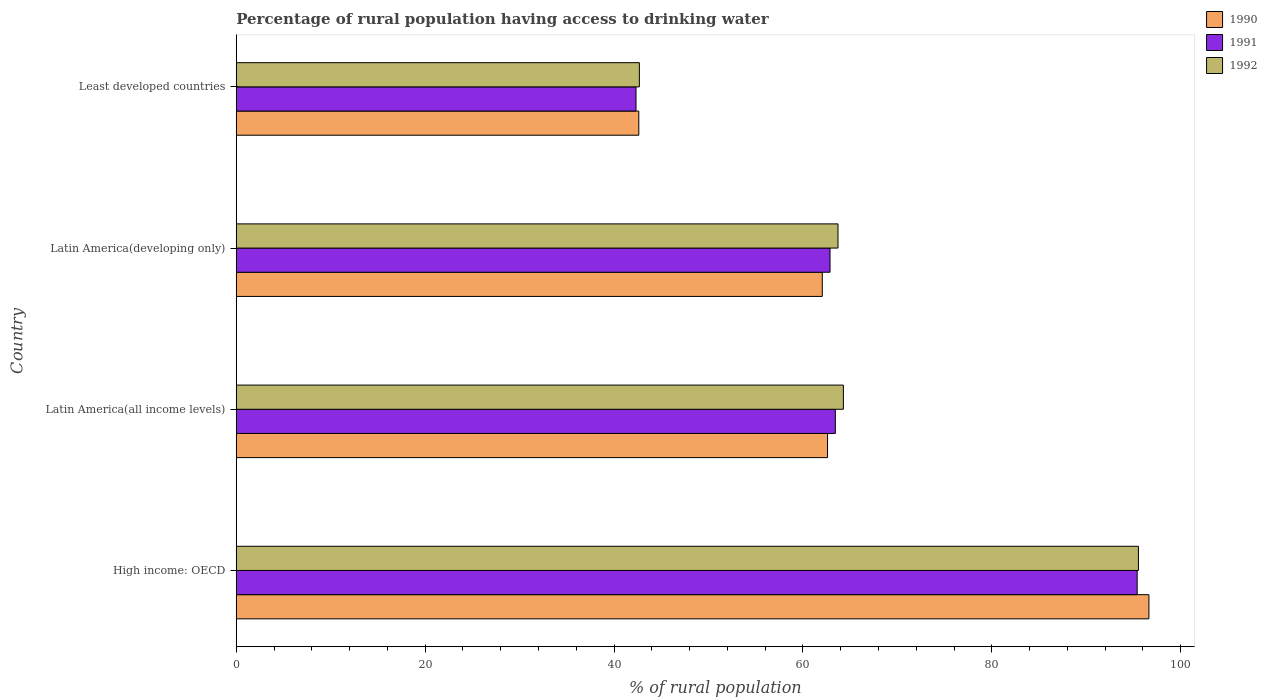How many bars are there on the 2nd tick from the top?
Give a very brief answer. 3. What is the label of the 2nd group of bars from the top?
Your answer should be compact. Latin America(developing only). What is the percentage of rural population having access to drinking water in 1992 in High income: OECD?
Give a very brief answer. 95.52. Across all countries, what is the maximum percentage of rural population having access to drinking water in 1990?
Provide a succinct answer. 96.63. Across all countries, what is the minimum percentage of rural population having access to drinking water in 1992?
Provide a succinct answer. 42.68. In which country was the percentage of rural population having access to drinking water in 1991 maximum?
Give a very brief answer. High income: OECD. In which country was the percentage of rural population having access to drinking water in 1992 minimum?
Ensure brevity in your answer.  Least developed countries. What is the total percentage of rural population having access to drinking water in 1991 in the graph?
Offer a very short reply. 264.02. What is the difference between the percentage of rural population having access to drinking water in 1991 in Latin America(developing only) and that in Least developed countries?
Offer a terse response. 20.54. What is the difference between the percentage of rural population having access to drinking water in 1990 in Latin America(all income levels) and the percentage of rural population having access to drinking water in 1992 in Latin America(developing only)?
Provide a succinct answer. -1.11. What is the average percentage of rural population having access to drinking water in 1992 per country?
Offer a very short reply. 66.55. What is the difference between the percentage of rural population having access to drinking water in 1991 and percentage of rural population having access to drinking water in 1992 in High income: OECD?
Your answer should be very brief. -0.14. In how many countries, is the percentage of rural population having access to drinking water in 1991 greater than 80 %?
Ensure brevity in your answer.  1. What is the ratio of the percentage of rural population having access to drinking water in 1990 in Latin America(all income levels) to that in Least developed countries?
Offer a terse response. 1.47. Is the percentage of rural population having access to drinking water in 1991 in High income: OECD less than that in Latin America(all income levels)?
Your answer should be very brief. No. What is the difference between the highest and the second highest percentage of rural population having access to drinking water in 1991?
Your response must be concise. 31.96. What is the difference between the highest and the lowest percentage of rural population having access to drinking water in 1992?
Keep it short and to the point. 52.84. In how many countries, is the percentage of rural population having access to drinking water in 1990 greater than the average percentage of rural population having access to drinking water in 1990 taken over all countries?
Provide a short and direct response. 1. Is the sum of the percentage of rural population having access to drinking water in 1990 in High income: OECD and Latin America(developing only) greater than the maximum percentage of rural population having access to drinking water in 1991 across all countries?
Give a very brief answer. Yes. What does the 2nd bar from the top in Latin America(developing only) represents?
Keep it short and to the point. 1991. What does the 3rd bar from the bottom in Latin America(developing only) represents?
Provide a succinct answer. 1992. Is it the case that in every country, the sum of the percentage of rural population having access to drinking water in 1990 and percentage of rural population having access to drinking water in 1992 is greater than the percentage of rural population having access to drinking water in 1991?
Provide a succinct answer. Yes. How many countries are there in the graph?
Provide a succinct answer. 4. Are the values on the major ticks of X-axis written in scientific E-notation?
Give a very brief answer. No. Does the graph contain grids?
Give a very brief answer. No. How many legend labels are there?
Give a very brief answer. 3. What is the title of the graph?
Offer a very short reply. Percentage of rural population having access to drinking water. Does "1991" appear as one of the legend labels in the graph?
Your answer should be compact. Yes. What is the label or title of the X-axis?
Provide a short and direct response. % of rural population. What is the label or title of the Y-axis?
Make the answer very short. Country. What is the % of rural population in 1990 in High income: OECD?
Make the answer very short. 96.63. What is the % of rural population in 1991 in High income: OECD?
Provide a short and direct response. 95.39. What is the % of rural population in 1992 in High income: OECD?
Offer a terse response. 95.52. What is the % of rural population in 1990 in Latin America(all income levels)?
Ensure brevity in your answer.  62.61. What is the % of rural population in 1991 in Latin America(all income levels)?
Your answer should be compact. 63.43. What is the % of rural population in 1992 in Latin America(all income levels)?
Ensure brevity in your answer.  64.28. What is the % of rural population in 1990 in Latin America(developing only)?
Provide a short and direct response. 62.05. What is the % of rural population of 1991 in Latin America(developing only)?
Offer a very short reply. 62.87. What is the % of rural population of 1992 in Latin America(developing only)?
Make the answer very short. 63.71. What is the % of rural population in 1990 in Least developed countries?
Provide a short and direct response. 42.62. What is the % of rural population of 1991 in Least developed countries?
Your response must be concise. 42.33. What is the % of rural population in 1992 in Least developed countries?
Your answer should be compact. 42.68. Across all countries, what is the maximum % of rural population of 1990?
Keep it short and to the point. 96.63. Across all countries, what is the maximum % of rural population in 1991?
Your answer should be very brief. 95.39. Across all countries, what is the maximum % of rural population in 1992?
Ensure brevity in your answer.  95.52. Across all countries, what is the minimum % of rural population in 1990?
Your answer should be very brief. 42.62. Across all countries, what is the minimum % of rural population in 1991?
Give a very brief answer. 42.33. Across all countries, what is the minimum % of rural population in 1992?
Offer a very short reply. 42.68. What is the total % of rural population of 1990 in the graph?
Your answer should be compact. 263.91. What is the total % of rural population in 1991 in the graph?
Make the answer very short. 264.01. What is the total % of rural population of 1992 in the graph?
Offer a very short reply. 266.2. What is the difference between the % of rural population of 1990 in High income: OECD and that in Latin America(all income levels)?
Provide a short and direct response. 34.03. What is the difference between the % of rural population in 1991 in High income: OECD and that in Latin America(all income levels)?
Keep it short and to the point. 31.96. What is the difference between the % of rural population of 1992 in High income: OECD and that in Latin America(all income levels)?
Ensure brevity in your answer.  31.24. What is the difference between the % of rural population of 1990 in High income: OECD and that in Latin America(developing only)?
Your answer should be very brief. 34.58. What is the difference between the % of rural population of 1991 in High income: OECD and that in Latin America(developing only)?
Your answer should be compact. 32.52. What is the difference between the % of rural population of 1992 in High income: OECD and that in Latin America(developing only)?
Ensure brevity in your answer.  31.81. What is the difference between the % of rural population of 1990 in High income: OECD and that in Least developed countries?
Your response must be concise. 54.01. What is the difference between the % of rural population of 1991 in High income: OECD and that in Least developed countries?
Ensure brevity in your answer.  53.06. What is the difference between the % of rural population in 1992 in High income: OECD and that in Least developed countries?
Your response must be concise. 52.84. What is the difference between the % of rural population of 1990 in Latin America(all income levels) and that in Latin America(developing only)?
Keep it short and to the point. 0.56. What is the difference between the % of rural population in 1991 in Latin America(all income levels) and that in Latin America(developing only)?
Ensure brevity in your answer.  0.56. What is the difference between the % of rural population of 1990 in Latin America(all income levels) and that in Least developed countries?
Provide a succinct answer. 19.99. What is the difference between the % of rural population in 1991 in Latin America(all income levels) and that in Least developed countries?
Ensure brevity in your answer.  21.11. What is the difference between the % of rural population of 1992 in Latin America(all income levels) and that in Least developed countries?
Provide a succinct answer. 21.6. What is the difference between the % of rural population in 1990 in Latin America(developing only) and that in Least developed countries?
Your answer should be very brief. 19.43. What is the difference between the % of rural population in 1991 in Latin America(developing only) and that in Least developed countries?
Provide a succinct answer. 20.54. What is the difference between the % of rural population of 1992 in Latin America(developing only) and that in Least developed countries?
Your response must be concise. 21.03. What is the difference between the % of rural population of 1990 in High income: OECD and the % of rural population of 1991 in Latin America(all income levels)?
Your answer should be compact. 33.2. What is the difference between the % of rural population of 1990 in High income: OECD and the % of rural population of 1992 in Latin America(all income levels)?
Your response must be concise. 32.35. What is the difference between the % of rural population in 1991 in High income: OECD and the % of rural population in 1992 in Latin America(all income levels)?
Ensure brevity in your answer.  31.1. What is the difference between the % of rural population in 1990 in High income: OECD and the % of rural population in 1991 in Latin America(developing only)?
Make the answer very short. 33.76. What is the difference between the % of rural population in 1990 in High income: OECD and the % of rural population in 1992 in Latin America(developing only)?
Offer a terse response. 32.92. What is the difference between the % of rural population in 1991 in High income: OECD and the % of rural population in 1992 in Latin America(developing only)?
Provide a succinct answer. 31.67. What is the difference between the % of rural population in 1990 in High income: OECD and the % of rural population in 1991 in Least developed countries?
Offer a terse response. 54.31. What is the difference between the % of rural population in 1990 in High income: OECD and the % of rural population in 1992 in Least developed countries?
Give a very brief answer. 53.95. What is the difference between the % of rural population of 1991 in High income: OECD and the % of rural population of 1992 in Least developed countries?
Offer a very short reply. 52.7. What is the difference between the % of rural population in 1990 in Latin America(all income levels) and the % of rural population in 1991 in Latin America(developing only)?
Make the answer very short. -0.26. What is the difference between the % of rural population in 1990 in Latin America(all income levels) and the % of rural population in 1992 in Latin America(developing only)?
Ensure brevity in your answer.  -1.11. What is the difference between the % of rural population of 1991 in Latin America(all income levels) and the % of rural population of 1992 in Latin America(developing only)?
Offer a terse response. -0.28. What is the difference between the % of rural population of 1990 in Latin America(all income levels) and the % of rural population of 1991 in Least developed countries?
Provide a short and direct response. 20.28. What is the difference between the % of rural population in 1990 in Latin America(all income levels) and the % of rural population in 1992 in Least developed countries?
Keep it short and to the point. 19.92. What is the difference between the % of rural population of 1991 in Latin America(all income levels) and the % of rural population of 1992 in Least developed countries?
Your response must be concise. 20.75. What is the difference between the % of rural population of 1990 in Latin America(developing only) and the % of rural population of 1991 in Least developed countries?
Offer a very short reply. 19.72. What is the difference between the % of rural population of 1990 in Latin America(developing only) and the % of rural population of 1992 in Least developed countries?
Your response must be concise. 19.37. What is the difference between the % of rural population of 1991 in Latin America(developing only) and the % of rural population of 1992 in Least developed countries?
Make the answer very short. 20.19. What is the average % of rural population of 1990 per country?
Ensure brevity in your answer.  65.98. What is the average % of rural population in 1991 per country?
Provide a succinct answer. 66. What is the average % of rural population of 1992 per country?
Your answer should be very brief. 66.55. What is the difference between the % of rural population in 1990 and % of rural population in 1991 in High income: OECD?
Offer a terse response. 1.25. What is the difference between the % of rural population in 1990 and % of rural population in 1992 in High income: OECD?
Provide a short and direct response. 1.11. What is the difference between the % of rural population of 1991 and % of rural population of 1992 in High income: OECD?
Offer a very short reply. -0.14. What is the difference between the % of rural population of 1990 and % of rural population of 1991 in Latin America(all income levels)?
Offer a terse response. -0.83. What is the difference between the % of rural population of 1990 and % of rural population of 1992 in Latin America(all income levels)?
Make the answer very short. -1.68. What is the difference between the % of rural population in 1991 and % of rural population in 1992 in Latin America(all income levels)?
Make the answer very short. -0.85. What is the difference between the % of rural population in 1990 and % of rural population in 1991 in Latin America(developing only)?
Your response must be concise. -0.82. What is the difference between the % of rural population of 1990 and % of rural population of 1992 in Latin America(developing only)?
Ensure brevity in your answer.  -1.66. What is the difference between the % of rural population in 1991 and % of rural population in 1992 in Latin America(developing only)?
Your answer should be very brief. -0.84. What is the difference between the % of rural population in 1990 and % of rural population in 1991 in Least developed countries?
Offer a very short reply. 0.29. What is the difference between the % of rural population in 1990 and % of rural population in 1992 in Least developed countries?
Keep it short and to the point. -0.06. What is the difference between the % of rural population of 1991 and % of rural population of 1992 in Least developed countries?
Provide a succinct answer. -0.36. What is the ratio of the % of rural population in 1990 in High income: OECD to that in Latin America(all income levels)?
Offer a terse response. 1.54. What is the ratio of the % of rural population in 1991 in High income: OECD to that in Latin America(all income levels)?
Offer a very short reply. 1.5. What is the ratio of the % of rural population of 1992 in High income: OECD to that in Latin America(all income levels)?
Your answer should be very brief. 1.49. What is the ratio of the % of rural population of 1990 in High income: OECD to that in Latin America(developing only)?
Your answer should be very brief. 1.56. What is the ratio of the % of rural population in 1991 in High income: OECD to that in Latin America(developing only)?
Your answer should be compact. 1.52. What is the ratio of the % of rural population of 1992 in High income: OECD to that in Latin America(developing only)?
Keep it short and to the point. 1.5. What is the ratio of the % of rural population of 1990 in High income: OECD to that in Least developed countries?
Offer a very short reply. 2.27. What is the ratio of the % of rural population in 1991 in High income: OECD to that in Least developed countries?
Keep it short and to the point. 2.25. What is the ratio of the % of rural population of 1992 in High income: OECD to that in Least developed countries?
Give a very brief answer. 2.24. What is the ratio of the % of rural population of 1990 in Latin America(all income levels) to that in Latin America(developing only)?
Offer a terse response. 1.01. What is the ratio of the % of rural population of 1991 in Latin America(all income levels) to that in Latin America(developing only)?
Give a very brief answer. 1.01. What is the ratio of the % of rural population in 1990 in Latin America(all income levels) to that in Least developed countries?
Offer a very short reply. 1.47. What is the ratio of the % of rural population of 1991 in Latin America(all income levels) to that in Least developed countries?
Give a very brief answer. 1.5. What is the ratio of the % of rural population in 1992 in Latin America(all income levels) to that in Least developed countries?
Provide a short and direct response. 1.51. What is the ratio of the % of rural population of 1990 in Latin America(developing only) to that in Least developed countries?
Offer a terse response. 1.46. What is the ratio of the % of rural population of 1991 in Latin America(developing only) to that in Least developed countries?
Give a very brief answer. 1.49. What is the ratio of the % of rural population in 1992 in Latin America(developing only) to that in Least developed countries?
Make the answer very short. 1.49. What is the difference between the highest and the second highest % of rural population of 1990?
Your response must be concise. 34.03. What is the difference between the highest and the second highest % of rural population of 1991?
Provide a succinct answer. 31.96. What is the difference between the highest and the second highest % of rural population in 1992?
Provide a succinct answer. 31.24. What is the difference between the highest and the lowest % of rural population in 1990?
Keep it short and to the point. 54.01. What is the difference between the highest and the lowest % of rural population in 1991?
Offer a very short reply. 53.06. What is the difference between the highest and the lowest % of rural population in 1992?
Your answer should be very brief. 52.84. 